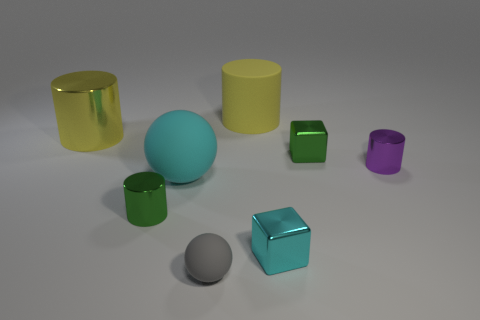What number of metallic cubes are the same color as the large ball?
Ensure brevity in your answer.  1. What number of things are either cylinders that are in front of the cyan matte ball or big yellow things on the left side of the tiny gray ball?
Provide a short and direct response. 2. Is the number of small shiny blocks greater than the number of cyan rubber things?
Your response must be concise. Yes. There is a metal cylinder that is on the right side of the small ball; what is its color?
Provide a short and direct response. Purple. Do the large yellow metallic object and the purple thing have the same shape?
Your response must be concise. Yes. There is a big thing that is behind the large cyan ball and in front of the yellow rubber cylinder; what is its color?
Give a very brief answer. Yellow. Does the gray matte thing that is in front of the cyan ball have the same size as the matte cylinder left of the purple cylinder?
Ensure brevity in your answer.  No. How many objects are either big matte cylinders behind the large yellow metal object or tiny red cylinders?
Keep it short and to the point. 1. What material is the small purple object?
Keep it short and to the point. Metal. Is the green metallic cube the same size as the yellow rubber object?
Offer a terse response. No. 